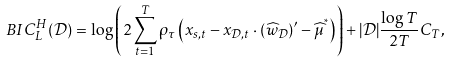Convert formula to latex. <formula><loc_0><loc_0><loc_500><loc_500>B I C _ { L } ^ { H } ( \mathcal { D } ) = \log \left ( 2 \sum _ { t = 1 } ^ { T } \rho _ { \tau } \left ( x _ { s , t } - x _ { \mathcal { D } , t } \cdot ( \widehat { w } _ { \mathcal { D } } ) ^ { \prime } - \widehat { \mu } ^ { ^ { * } } \right ) \right ) + | \mathcal { D } | \frac { \log T } { 2 T } C _ { T } ,</formula> 